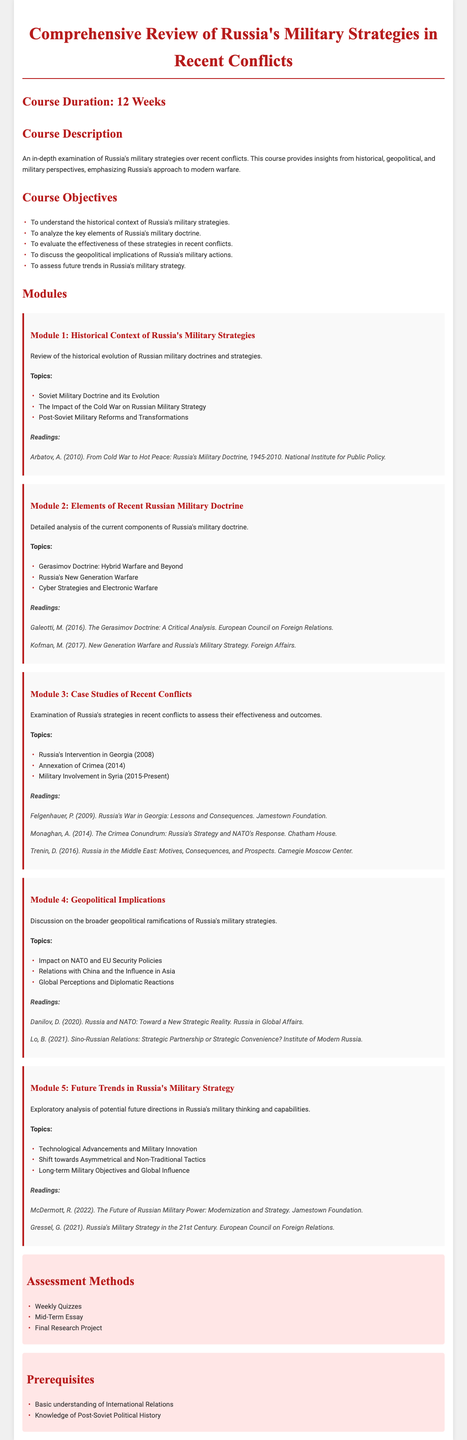What is the course duration? The course duration is explicitly stated in the document as 12 weeks.
Answer: 12 Weeks What is the first module about? The first module focuses on the historical context, specifically the evolution of Russian military doctrines and strategies.
Answer: Historical Context of Russia's Military Strategies Who authored the reading for Module 1? The reading for Module 1 is authored by Arbatov, A. as mentioned in the readings section.
Answer: Arbatov, A What is one topic covered in Module 3? One of the topics covered in Module 3 is Russia's Intervention in Georgia (2008), as listed under the module topics.
Answer: Russia's Intervention in Georgia (2008) What assessment methods are used in the course? The assessment methods are specified in a section detailing how students will be evaluated, including weekly quizzes and other methods.
Answer: Weekly Quizzes How many key elements of Russia's military doctrine are highlighted? The course objectives outline five specific key elements regarding Russia's military doctrine.
Answer: Five What is the prerequisite for the course? The prerequisites include a basic understanding of International Relations.
Answer: Basic understanding of International Relations Which reading discusses Sino-Russian relations? The document mentions Lo, B. as the author discussing Sino-Russian relations in the readings for Module 4.
Answer: Lo, B 